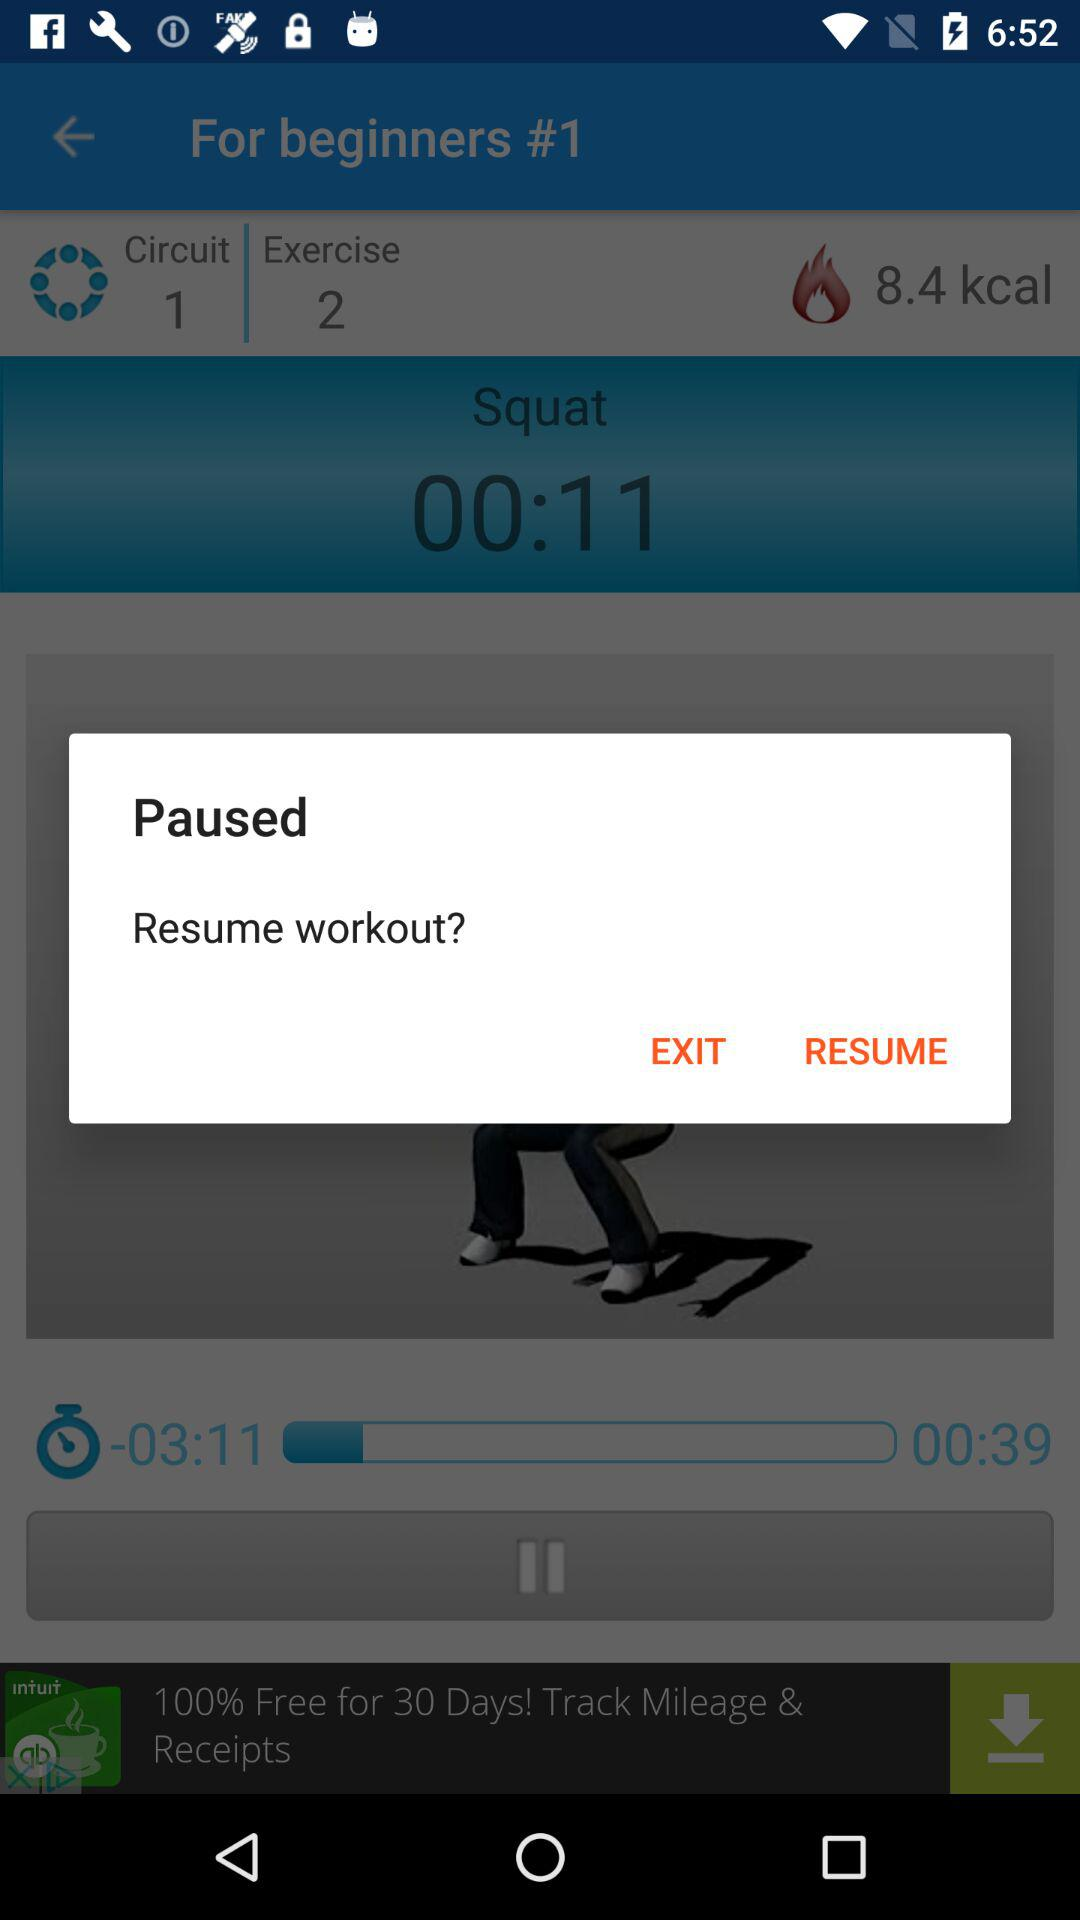From where can we download the S Health app? You can download it from "Google Play". 